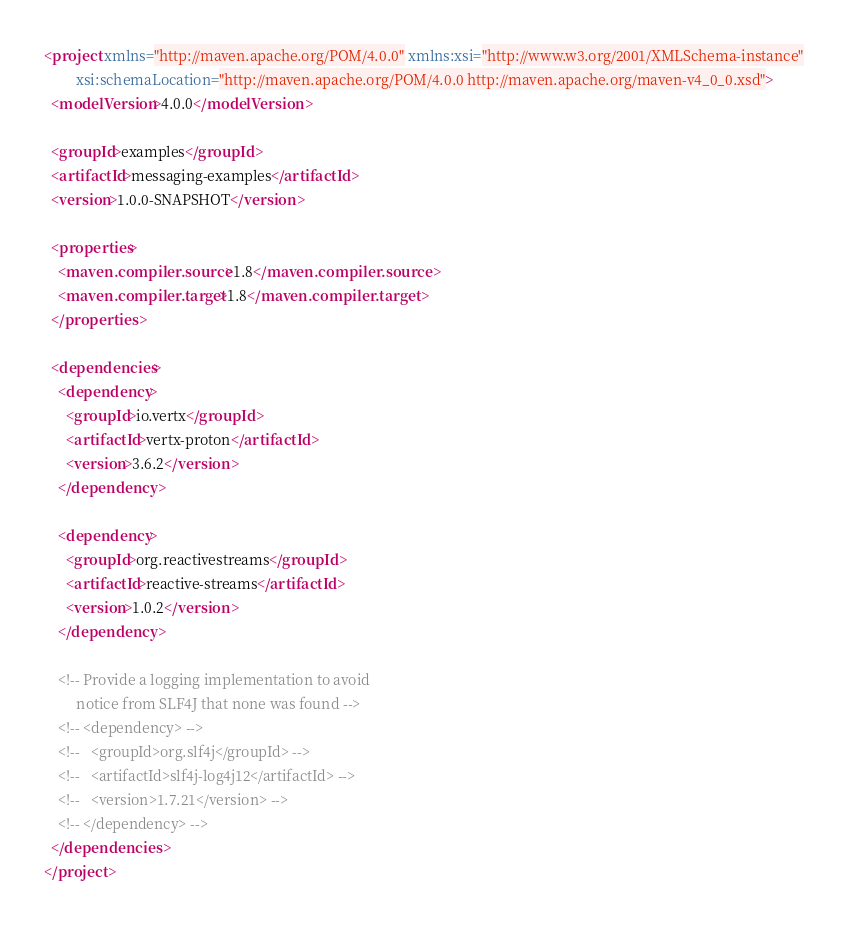Convert code to text. <code><loc_0><loc_0><loc_500><loc_500><_XML_><project xmlns="http://maven.apache.org/POM/4.0.0" xmlns:xsi="http://www.w3.org/2001/XMLSchema-instance"
         xsi:schemaLocation="http://maven.apache.org/POM/4.0.0 http://maven.apache.org/maven-v4_0_0.xsd">
  <modelVersion>4.0.0</modelVersion>

  <groupId>examples</groupId>
  <artifactId>messaging-examples</artifactId>
  <version>1.0.0-SNAPSHOT</version>

  <properties>
    <maven.compiler.source>1.8</maven.compiler.source>
    <maven.compiler.target>1.8</maven.compiler.target>
  </properties>

  <dependencies>
    <dependency>
      <groupId>io.vertx</groupId>
      <artifactId>vertx-proton</artifactId>
      <version>3.6.2</version>
    </dependency>

    <dependency>
      <groupId>org.reactivestreams</groupId>
      <artifactId>reactive-streams</artifactId>
      <version>1.0.2</version>
    </dependency>

    <!-- Provide a logging implementation to avoid
         notice from SLF4J that none was found -->
    <!-- <dependency> -->
    <!--   <groupId>org.slf4j</groupId> -->
    <!--   <artifactId>slf4j-log4j12</artifactId> -->
    <!--   <version>1.7.21</version> -->
    <!-- </dependency> -->
  </dependencies>
</project>
</code> 